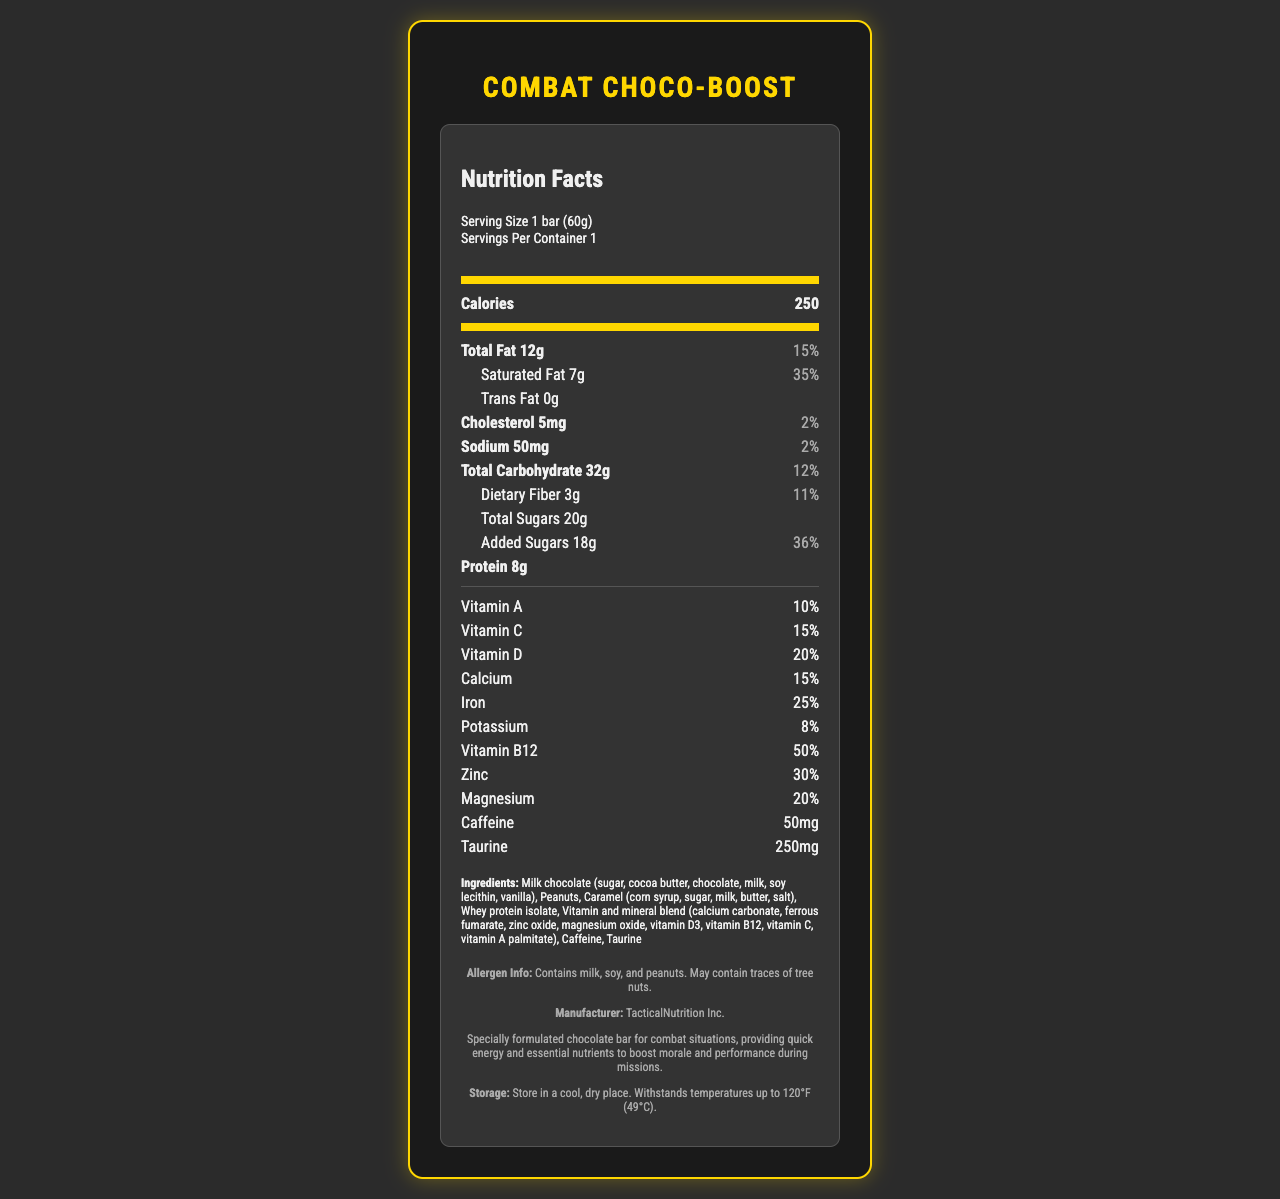What is the serving size of the Combat Choco-Boost? The serving size is listed as "1 bar (60g)" at the top of the nutrition label.
Answer: 1 bar (60g) How many calories are in one serving? The number of calories per serving is indicated as 250 on the nutrition label.
Answer: 250 What percentage of daily value does saturated fat represent? The daily value percentage for saturated fat is listed as 35% on the nutrition label.
Answer: 35% How many grams of dietary fiber are in one serving? The nutrition label shows that there are 3 grams of dietary fiber per serving.
Answer: 3g What is the amount of vitamin B12 in Combat Choco-Boost? The amount of vitamin B12 is denoted as 50% of the daily value on the nutrition label.
Answer: 50% How much protein does one bar of Combat Choco-Boost contain? The nutrition label specifies that each bar contains 8 grams of protein.
Answer: 8g Which of the following ingredients might cause an allergic reaction in someone with a tree nut allergy? A. Soy lecithin B. Peanuts C. Taurine The allergen info states the product contains peanuts and may contain traces of tree nuts, making "Peanuts" the correct answer.
Answer: B What is the amount of caffeine in each bar? A. 50mg B. 100mg C. 25mg D. 200mg The amount of caffeine is listed as 50mg in the nutrition label, making "50mg" the correct answer.
Answer: A Is the amount of trans fat in the Combat Choco-Boost more than 1 gram? The label indicates that trans fat content is 0g, so it is not more than 1 gram.
Answer: No Summarize the primary nutritional components and purpose of Combat Choco-Boost. The document describes Combat Choco-Boost extensively, detailing its nutrient composition including macronutrients (calories, fats, carbohydrates, protein), vitamins, minerals, caffeine, and taurine. The bar is designed to provide quick energy and essential nutrients for military personnel during missions.
Answer: Combat Choco-Boost is a nutrient-fortified chocolate bar designed to provide quick energy and essential nutrients to boost morale and performance during missions. It contains significant amounts of calories, fats, carbohydrates, protein, and various vitamins and minerals. It also includes caffeine and taurine for additional energy and focus. What is the sodium content per serving? The nutrition label states that the sodium content per serving is 50mg.
Answer: 50mg What is the total amount of sugars (including added sugars) in each bar? The total amount of sugars, indicated on the nutrition label, is 20g.
Answer: 20g Who is the manufacturer of Combat Choco-Boost? The product information section states that the manufacturer is TacticalNutrition Inc.
Answer: TacticalNutrition Inc. How much iron is in one bar of Combat Choco-Boost? The nutrition label indicates that the amount of iron is 25% of the daily value.
Answer: 25% Can the exact temperature tolerance during storage be determined from the document? The document states that the bar withstands temperatures up to 120°F (49°C) under storage instructions.
Answer: Yes What other ingredient, besides caffeine, is included in the Combat Choco-Boost for an energy boost? Besides caffeine, taurine is listed as an ingredient and is known for its energy-boosting properties.
Answer: Taurine What flavors or taste notes might be expected in Combat Choco-Boost based on its ingredients? Based on the ingredients list including milk chocolate, caramel, peanuts, and vanilla, the expected flavors or taste notes would be chocolate, vanilla, caramel, peanuts, butter, and salt.
Answer: Chocolate, vanilla, caramel, peanuts, butter, salt Can you determine the exact number of tree nuts the product may contain? The document only states that the product may contain traces of tree nuts but does not specify the exact number.
Answer: Cannot be determined 